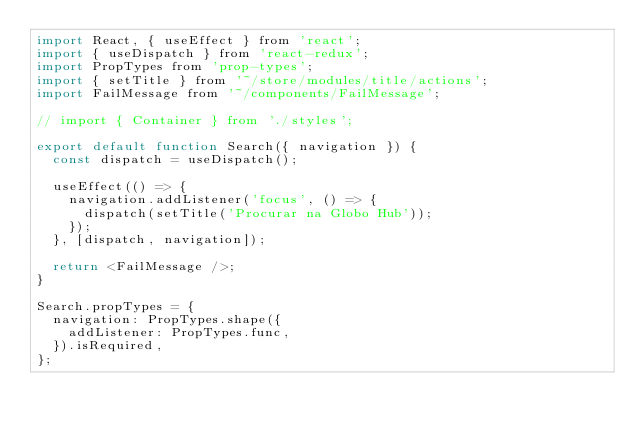<code> <loc_0><loc_0><loc_500><loc_500><_JavaScript_>import React, { useEffect } from 'react';
import { useDispatch } from 'react-redux';
import PropTypes from 'prop-types';
import { setTitle } from '~/store/modules/title/actions';
import FailMessage from '~/components/FailMessage';

// import { Container } from './styles';

export default function Search({ navigation }) {
  const dispatch = useDispatch();

  useEffect(() => {
    navigation.addListener('focus', () => {
      dispatch(setTitle('Procurar na Globo Hub'));
    });
  }, [dispatch, navigation]);

  return <FailMessage />;
}

Search.propTypes = {
  navigation: PropTypes.shape({
    addListener: PropTypes.func,
  }).isRequired,
};
</code> 